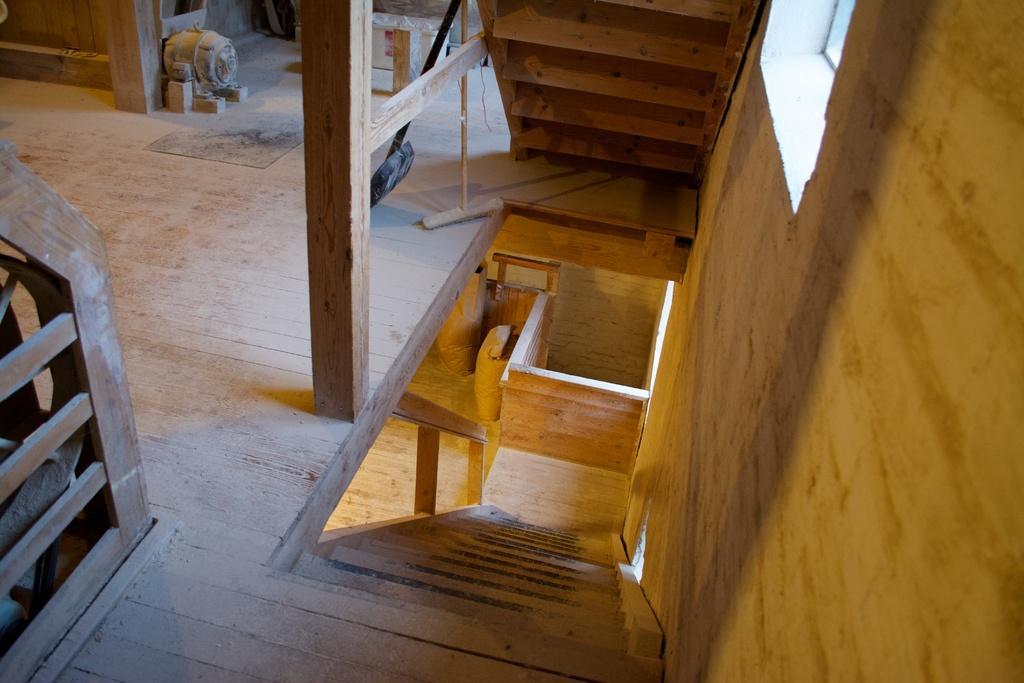In one or two sentences, can you explain what this image depicts? In this image I can see it is an inside part of a wooden house, this is the staircase. 